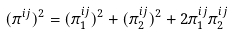<formula> <loc_0><loc_0><loc_500><loc_500>( \pi ^ { i j } ) ^ { 2 } = ( \pi ^ { i j } _ { 1 } ) ^ { 2 } + ( \pi ^ { i j } _ { 2 } ) ^ { 2 } + 2 \pi ^ { i j } _ { 1 } \pi ^ { i j } _ { 2 }</formula> 